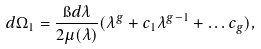Convert formula to latex. <formula><loc_0><loc_0><loc_500><loc_500>d \Omega _ { 1 } = \frac { \i d \lambda } { 2 \mu ( \lambda ) } ( \lambda ^ { g } + c _ { 1 } \lambda ^ { g - 1 } + \dots c _ { g } ) ,</formula> 